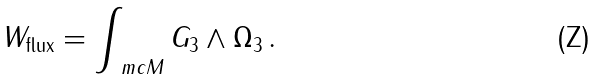Convert formula to latex. <formula><loc_0><loc_0><loc_500><loc_500>W _ { \text {flux} } = \int _ { \ m c { M } } G _ { 3 } \wedge \Omega _ { 3 } \, .</formula> 